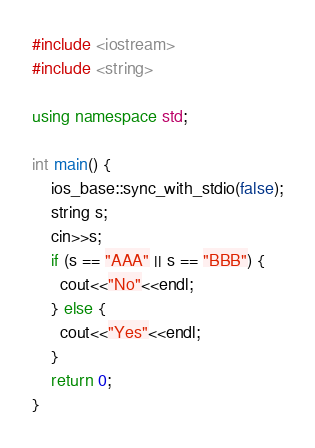<code> <loc_0><loc_0><loc_500><loc_500><_C++_>#include <iostream>
#include <string>

using namespace std;

int main() {
	ios_base::sync_with_stdio(false);
  	string s;
  	cin>>s;
  	if (s == "AAA" || s == "BBB") {
      cout<<"No"<<endl;
    } else {
      cout<<"Yes"<<endl;
    }
  	return 0;
}</code> 